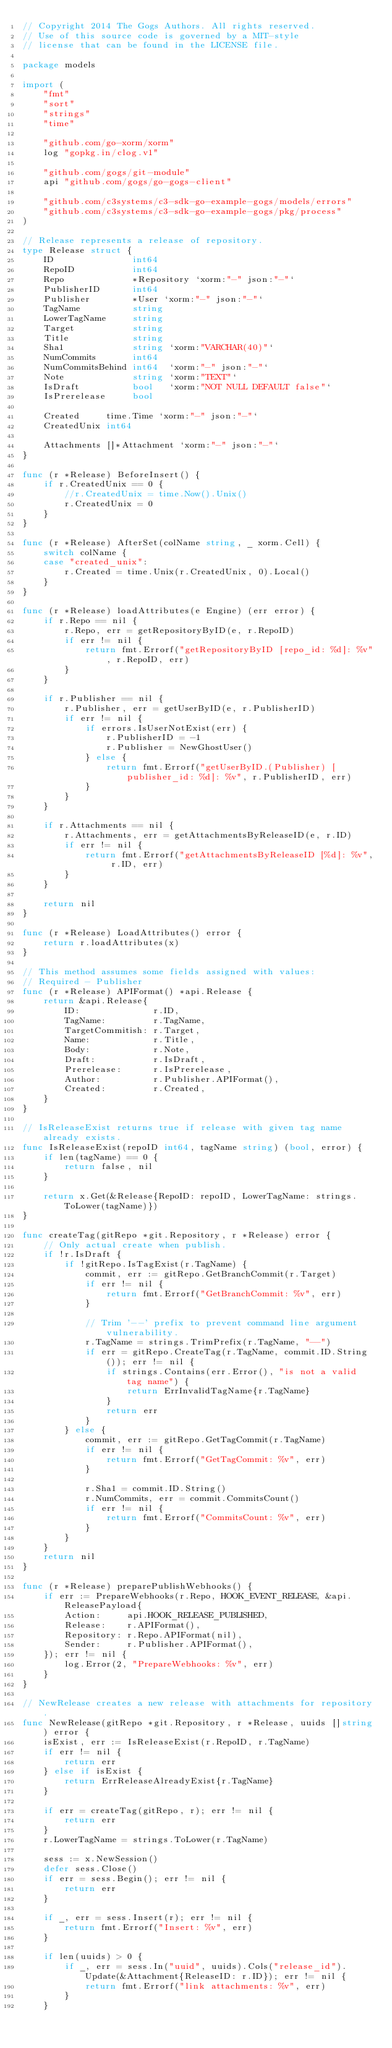<code> <loc_0><loc_0><loc_500><loc_500><_Go_>// Copyright 2014 The Gogs Authors. All rights reserved.
// Use of this source code is governed by a MIT-style
// license that can be found in the LICENSE file.

package models

import (
	"fmt"
	"sort"
	"strings"
	"time"

	"github.com/go-xorm/xorm"
	log "gopkg.in/clog.v1"

	"github.com/gogs/git-module"
	api "github.com/gogs/go-gogs-client"

	"github.com/c3systems/c3-sdk-go-example-gogs/models/errors"
	"github.com/c3systems/c3-sdk-go-example-gogs/pkg/process"
)

// Release represents a release of repository.
type Release struct {
	ID               int64
	RepoID           int64
	Repo             *Repository `xorm:"-" json:"-"`
	PublisherID      int64
	Publisher        *User `xorm:"-" json:"-"`
	TagName          string
	LowerTagName     string
	Target           string
	Title            string
	Sha1             string `xorm:"VARCHAR(40)"`
	NumCommits       int64
	NumCommitsBehind int64  `xorm:"-" json:"-"`
	Note             string `xorm:"TEXT"`
	IsDraft          bool   `xorm:"NOT NULL DEFAULT false"`
	IsPrerelease     bool

	Created     time.Time `xorm:"-" json:"-"`
	CreatedUnix int64

	Attachments []*Attachment `xorm:"-" json:"-"`
}

func (r *Release) BeforeInsert() {
	if r.CreatedUnix == 0 {
		//r.CreatedUnix = time.Now().Unix()
		r.CreatedUnix = 0
	}
}

func (r *Release) AfterSet(colName string, _ xorm.Cell) {
	switch colName {
	case "created_unix":
		r.Created = time.Unix(r.CreatedUnix, 0).Local()
	}
}

func (r *Release) loadAttributes(e Engine) (err error) {
	if r.Repo == nil {
		r.Repo, err = getRepositoryByID(e, r.RepoID)
		if err != nil {
			return fmt.Errorf("getRepositoryByID [repo_id: %d]: %v", r.RepoID, err)
		}
	}

	if r.Publisher == nil {
		r.Publisher, err = getUserByID(e, r.PublisherID)
		if err != nil {
			if errors.IsUserNotExist(err) {
				r.PublisherID = -1
				r.Publisher = NewGhostUser()
			} else {
				return fmt.Errorf("getUserByID.(Publisher) [publisher_id: %d]: %v", r.PublisherID, err)
			}
		}
	}

	if r.Attachments == nil {
		r.Attachments, err = getAttachmentsByReleaseID(e, r.ID)
		if err != nil {
			return fmt.Errorf("getAttachmentsByReleaseID [%d]: %v", r.ID, err)
		}
	}

	return nil
}

func (r *Release) LoadAttributes() error {
	return r.loadAttributes(x)
}

// This method assumes some fields assigned with values:
// Required - Publisher
func (r *Release) APIFormat() *api.Release {
	return &api.Release{
		ID:              r.ID,
		TagName:         r.TagName,
		TargetCommitish: r.Target,
		Name:            r.Title,
		Body:            r.Note,
		Draft:           r.IsDraft,
		Prerelease:      r.IsPrerelease,
		Author:          r.Publisher.APIFormat(),
		Created:         r.Created,
	}
}

// IsReleaseExist returns true if release with given tag name already exists.
func IsReleaseExist(repoID int64, tagName string) (bool, error) {
	if len(tagName) == 0 {
		return false, nil
	}

	return x.Get(&Release{RepoID: repoID, LowerTagName: strings.ToLower(tagName)})
}

func createTag(gitRepo *git.Repository, r *Release) error {
	// Only actual create when publish.
	if !r.IsDraft {
		if !gitRepo.IsTagExist(r.TagName) {
			commit, err := gitRepo.GetBranchCommit(r.Target)
			if err != nil {
				return fmt.Errorf("GetBranchCommit: %v", err)
			}

			// Trim '--' prefix to prevent command line argument vulnerability.
			r.TagName = strings.TrimPrefix(r.TagName, "--")
			if err = gitRepo.CreateTag(r.TagName, commit.ID.String()); err != nil {
				if strings.Contains(err.Error(), "is not a valid tag name") {
					return ErrInvalidTagName{r.TagName}
				}
				return err
			}
		} else {
			commit, err := gitRepo.GetTagCommit(r.TagName)
			if err != nil {
				return fmt.Errorf("GetTagCommit: %v", err)
			}

			r.Sha1 = commit.ID.String()
			r.NumCommits, err = commit.CommitsCount()
			if err != nil {
				return fmt.Errorf("CommitsCount: %v", err)
			}
		}
	}
	return nil
}

func (r *Release) preparePublishWebhooks() {
	if err := PrepareWebhooks(r.Repo, HOOK_EVENT_RELEASE, &api.ReleasePayload{
		Action:     api.HOOK_RELEASE_PUBLISHED,
		Release:    r.APIFormat(),
		Repository: r.Repo.APIFormat(nil),
		Sender:     r.Publisher.APIFormat(),
	}); err != nil {
		log.Error(2, "PrepareWebhooks: %v", err)
	}
}

// NewRelease creates a new release with attachments for repository.
func NewRelease(gitRepo *git.Repository, r *Release, uuids []string) error {
	isExist, err := IsReleaseExist(r.RepoID, r.TagName)
	if err != nil {
		return err
	} else if isExist {
		return ErrReleaseAlreadyExist{r.TagName}
	}

	if err = createTag(gitRepo, r); err != nil {
		return err
	}
	r.LowerTagName = strings.ToLower(r.TagName)

	sess := x.NewSession()
	defer sess.Close()
	if err = sess.Begin(); err != nil {
		return err
	}

	if _, err = sess.Insert(r); err != nil {
		return fmt.Errorf("Insert: %v", err)
	}

	if len(uuids) > 0 {
		if _, err = sess.In("uuid", uuids).Cols("release_id").Update(&Attachment{ReleaseID: r.ID}); err != nil {
			return fmt.Errorf("link attachments: %v", err)
		}
	}
</code> 